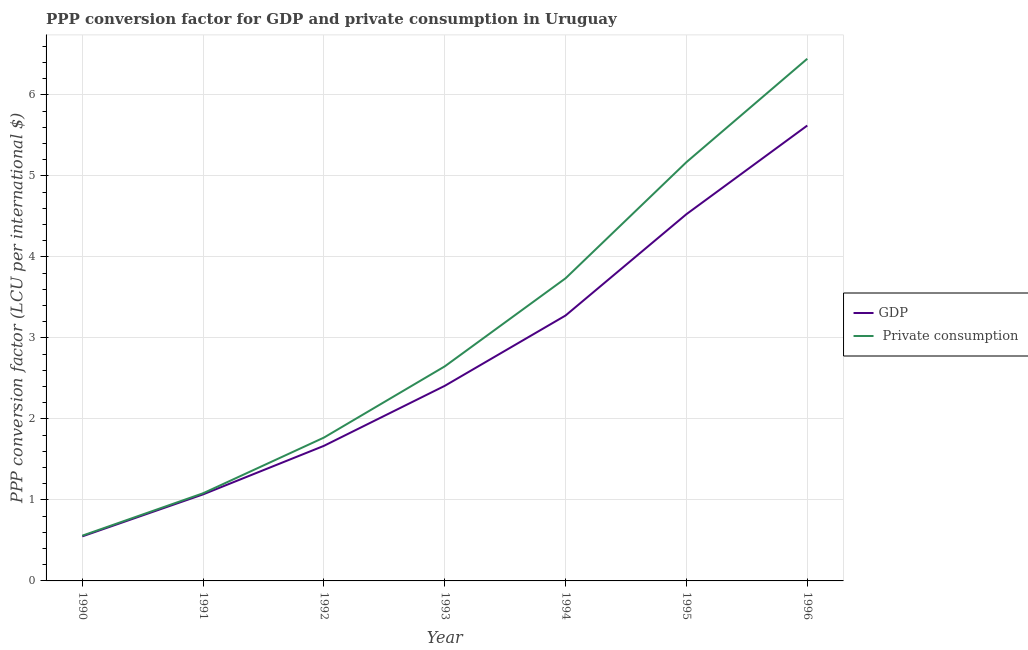How many different coloured lines are there?
Provide a succinct answer. 2. Does the line corresponding to ppp conversion factor for private consumption intersect with the line corresponding to ppp conversion factor for gdp?
Your response must be concise. No. Is the number of lines equal to the number of legend labels?
Your response must be concise. Yes. What is the ppp conversion factor for gdp in 1996?
Offer a terse response. 5.62. Across all years, what is the maximum ppp conversion factor for private consumption?
Give a very brief answer. 6.45. Across all years, what is the minimum ppp conversion factor for gdp?
Make the answer very short. 0.55. In which year was the ppp conversion factor for gdp maximum?
Offer a terse response. 1996. What is the total ppp conversion factor for gdp in the graph?
Your response must be concise. 19.12. What is the difference between the ppp conversion factor for private consumption in 1990 and that in 1991?
Provide a succinct answer. -0.52. What is the difference between the ppp conversion factor for gdp in 1993 and the ppp conversion factor for private consumption in 1992?
Provide a short and direct response. 0.64. What is the average ppp conversion factor for private consumption per year?
Provide a succinct answer. 3.06. In the year 1994, what is the difference between the ppp conversion factor for private consumption and ppp conversion factor for gdp?
Your answer should be very brief. 0.46. What is the ratio of the ppp conversion factor for private consumption in 1991 to that in 1995?
Provide a short and direct response. 0.21. What is the difference between the highest and the second highest ppp conversion factor for private consumption?
Your answer should be very brief. 1.28. What is the difference between the highest and the lowest ppp conversion factor for private consumption?
Provide a succinct answer. 5.89. In how many years, is the ppp conversion factor for private consumption greater than the average ppp conversion factor for private consumption taken over all years?
Your response must be concise. 3. Is the sum of the ppp conversion factor for gdp in 1992 and 1995 greater than the maximum ppp conversion factor for private consumption across all years?
Provide a succinct answer. No. Does the ppp conversion factor for private consumption monotonically increase over the years?
Ensure brevity in your answer.  Yes. Is the ppp conversion factor for private consumption strictly greater than the ppp conversion factor for gdp over the years?
Provide a succinct answer. Yes. Is the ppp conversion factor for gdp strictly less than the ppp conversion factor for private consumption over the years?
Provide a short and direct response. Yes. How many lines are there?
Provide a short and direct response. 2. Are the values on the major ticks of Y-axis written in scientific E-notation?
Provide a succinct answer. No. Does the graph contain any zero values?
Offer a very short reply. No. How many legend labels are there?
Your answer should be very brief. 2. How are the legend labels stacked?
Offer a very short reply. Vertical. What is the title of the graph?
Provide a succinct answer. PPP conversion factor for GDP and private consumption in Uruguay. What is the label or title of the Y-axis?
Provide a succinct answer. PPP conversion factor (LCU per international $). What is the PPP conversion factor (LCU per international $) of GDP in 1990?
Ensure brevity in your answer.  0.55. What is the PPP conversion factor (LCU per international $) in  Private consumption in 1990?
Your answer should be very brief. 0.56. What is the PPP conversion factor (LCU per international $) of GDP in 1991?
Your answer should be very brief. 1.07. What is the PPP conversion factor (LCU per international $) of  Private consumption in 1991?
Offer a terse response. 1.08. What is the PPP conversion factor (LCU per international $) of GDP in 1992?
Give a very brief answer. 1.67. What is the PPP conversion factor (LCU per international $) of  Private consumption in 1992?
Your response must be concise. 1.77. What is the PPP conversion factor (LCU per international $) of GDP in 1993?
Ensure brevity in your answer.  2.41. What is the PPP conversion factor (LCU per international $) in  Private consumption in 1993?
Make the answer very short. 2.65. What is the PPP conversion factor (LCU per international $) of GDP in 1994?
Your answer should be very brief. 3.28. What is the PPP conversion factor (LCU per international $) in  Private consumption in 1994?
Keep it short and to the point. 3.74. What is the PPP conversion factor (LCU per international $) of GDP in 1995?
Provide a succinct answer. 4.53. What is the PPP conversion factor (LCU per international $) in  Private consumption in 1995?
Offer a very short reply. 5.17. What is the PPP conversion factor (LCU per international $) of GDP in 1996?
Offer a very short reply. 5.62. What is the PPP conversion factor (LCU per international $) in  Private consumption in 1996?
Keep it short and to the point. 6.45. Across all years, what is the maximum PPP conversion factor (LCU per international $) of GDP?
Make the answer very short. 5.62. Across all years, what is the maximum PPP conversion factor (LCU per international $) in  Private consumption?
Provide a succinct answer. 6.45. Across all years, what is the minimum PPP conversion factor (LCU per international $) in GDP?
Offer a terse response. 0.55. Across all years, what is the minimum PPP conversion factor (LCU per international $) of  Private consumption?
Your answer should be very brief. 0.56. What is the total PPP conversion factor (LCU per international $) of GDP in the graph?
Offer a very short reply. 19.12. What is the total PPP conversion factor (LCU per international $) of  Private consumption in the graph?
Give a very brief answer. 21.41. What is the difference between the PPP conversion factor (LCU per international $) of GDP in 1990 and that in 1991?
Your response must be concise. -0.52. What is the difference between the PPP conversion factor (LCU per international $) of  Private consumption in 1990 and that in 1991?
Provide a succinct answer. -0.52. What is the difference between the PPP conversion factor (LCU per international $) of GDP in 1990 and that in 1992?
Keep it short and to the point. -1.12. What is the difference between the PPP conversion factor (LCU per international $) in  Private consumption in 1990 and that in 1992?
Offer a very short reply. -1.21. What is the difference between the PPP conversion factor (LCU per international $) of GDP in 1990 and that in 1993?
Your answer should be compact. -1.86. What is the difference between the PPP conversion factor (LCU per international $) in  Private consumption in 1990 and that in 1993?
Your answer should be very brief. -2.09. What is the difference between the PPP conversion factor (LCU per international $) in GDP in 1990 and that in 1994?
Your answer should be very brief. -2.73. What is the difference between the PPP conversion factor (LCU per international $) of  Private consumption in 1990 and that in 1994?
Give a very brief answer. -3.18. What is the difference between the PPP conversion factor (LCU per international $) of GDP in 1990 and that in 1995?
Keep it short and to the point. -3.98. What is the difference between the PPP conversion factor (LCU per international $) of  Private consumption in 1990 and that in 1995?
Your answer should be compact. -4.61. What is the difference between the PPP conversion factor (LCU per international $) of GDP in 1990 and that in 1996?
Your answer should be very brief. -5.07. What is the difference between the PPP conversion factor (LCU per international $) in  Private consumption in 1990 and that in 1996?
Your response must be concise. -5.89. What is the difference between the PPP conversion factor (LCU per international $) of GDP in 1991 and that in 1992?
Give a very brief answer. -0.6. What is the difference between the PPP conversion factor (LCU per international $) in  Private consumption in 1991 and that in 1992?
Your response must be concise. -0.69. What is the difference between the PPP conversion factor (LCU per international $) of GDP in 1991 and that in 1993?
Give a very brief answer. -1.34. What is the difference between the PPP conversion factor (LCU per international $) of  Private consumption in 1991 and that in 1993?
Provide a succinct answer. -1.57. What is the difference between the PPP conversion factor (LCU per international $) of GDP in 1991 and that in 1994?
Offer a terse response. -2.21. What is the difference between the PPP conversion factor (LCU per international $) in  Private consumption in 1991 and that in 1994?
Provide a succinct answer. -2.65. What is the difference between the PPP conversion factor (LCU per international $) in GDP in 1991 and that in 1995?
Your response must be concise. -3.46. What is the difference between the PPP conversion factor (LCU per international $) of  Private consumption in 1991 and that in 1995?
Your answer should be very brief. -4.09. What is the difference between the PPP conversion factor (LCU per international $) of GDP in 1991 and that in 1996?
Ensure brevity in your answer.  -4.55. What is the difference between the PPP conversion factor (LCU per international $) of  Private consumption in 1991 and that in 1996?
Your answer should be compact. -5.36. What is the difference between the PPP conversion factor (LCU per international $) of GDP in 1992 and that in 1993?
Keep it short and to the point. -0.74. What is the difference between the PPP conversion factor (LCU per international $) in  Private consumption in 1992 and that in 1993?
Provide a short and direct response. -0.88. What is the difference between the PPP conversion factor (LCU per international $) of GDP in 1992 and that in 1994?
Offer a terse response. -1.61. What is the difference between the PPP conversion factor (LCU per international $) of  Private consumption in 1992 and that in 1994?
Offer a very short reply. -1.97. What is the difference between the PPP conversion factor (LCU per international $) in GDP in 1992 and that in 1995?
Provide a short and direct response. -2.86. What is the difference between the PPP conversion factor (LCU per international $) of  Private consumption in 1992 and that in 1995?
Give a very brief answer. -3.4. What is the difference between the PPP conversion factor (LCU per international $) of GDP in 1992 and that in 1996?
Offer a terse response. -3.95. What is the difference between the PPP conversion factor (LCU per international $) of  Private consumption in 1992 and that in 1996?
Provide a succinct answer. -4.68. What is the difference between the PPP conversion factor (LCU per international $) of GDP in 1993 and that in 1994?
Offer a terse response. -0.87. What is the difference between the PPP conversion factor (LCU per international $) in  Private consumption in 1993 and that in 1994?
Keep it short and to the point. -1.09. What is the difference between the PPP conversion factor (LCU per international $) of GDP in 1993 and that in 1995?
Provide a short and direct response. -2.12. What is the difference between the PPP conversion factor (LCU per international $) of  Private consumption in 1993 and that in 1995?
Make the answer very short. -2.52. What is the difference between the PPP conversion factor (LCU per international $) of GDP in 1993 and that in 1996?
Keep it short and to the point. -3.21. What is the difference between the PPP conversion factor (LCU per international $) in  Private consumption in 1993 and that in 1996?
Your answer should be compact. -3.8. What is the difference between the PPP conversion factor (LCU per international $) in GDP in 1994 and that in 1995?
Keep it short and to the point. -1.25. What is the difference between the PPP conversion factor (LCU per international $) of  Private consumption in 1994 and that in 1995?
Make the answer very short. -1.43. What is the difference between the PPP conversion factor (LCU per international $) in GDP in 1994 and that in 1996?
Your response must be concise. -2.34. What is the difference between the PPP conversion factor (LCU per international $) in  Private consumption in 1994 and that in 1996?
Ensure brevity in your answer.  -2.71. What is the difference between the PPP conversion factor (LCU per international $) of GDP in 1995 and that in 1996?
Your answer should be compact. -1.09. What is the difference between the PPP conversion factor (LCU per international $) of  Private consumption in 1995 and that in 1996?
Provide a short and direct response. -1.28. What is the difference between the PPP conversion factor (LCU per international $) of GDP in 1990 and the PPP conversion factor (LCU per international $) of  Private consumption in 1991?
Your response must be concise. -0.53. What is the difference between the PPP conversion factor (LCU per international $) in GDP in 1990 and the PPP conversion factor (LCU per international $) in  Private consumption in 1992?
Provide a short and direct response. -1.22. What is the difference between the PPP conversion factor (LCU per international $) in GDP in 1990 and the PPP conversion factor (LCU per international $) in  Private consumption in 1993?
Offer a very short reply. -2.1. What is the difference between the PPP conversion factor (LCU per international $) of GDP in 1990 and the PPP conversion factor (LCU per international $) of  Private consumption in 1994?
Offer a very short reply. -3.19. What is the difference between the PPP conversion factor (LCU per international $) in GDP in 1990 and the PPP conversion factor (LCU per international $) in  Private consumption in 1995?
Provide a short and direct response. -4.62. What is the difference between the PPP conversion factor (LCU per international $) of GDP in 1990 and the PPP conversion factor (LCU per international $) of  Private consumption in 1996?
Offer a terse response. -5.9. What is the difference between the PPP conversion factor (LCU per international $) in GDP in 1991 and the PPP conversion factor (LCU per international $) in  Private consumption in 1992?
Provide a short and direct response. -0.7. What is the difference between the PPP conversion factor (LCU per international $) in GDP in 1991 and the PPP conversion factor (LCU per international $) in  Private consumption in 1993?
Provide a short and direct response. -1.58. What is the difference between the PPP conversion factor (LCU per international $) in GDP in 1991 and the PPP conversion factor (LCU per international $) in  Private consumption in 1994?
Your answer should be very brief. -2.67. What is the difference between the PPP conversion factor (LCU per international $) in GDP in 1991 and the PPP conversion factor (LCU per international $) in  Private consumption in 1995?
Your answer should be compact. -4.1. What is the difference between the PPP conversion factor (LCU per international $) in GDP in 1991 and the PPP conversion factor (LCU per international $) in  Private consumption in 1996?
Give a very brief answer. -5.38. What is the difference between the PPP conversion factor (LCU per international $) in GDP in 1992 and the PPP conversion factor (LCU per international $) in  Private consumption in 1993?
Make the answer very short. -0.98. What is the difference between the PPP conversion factor (LCU per international $) of GDP in 1992 and the PPP conversion factor (LCU per international $) of  Private consumption in 1994?
Your response must be concise. -2.07. What is the difference between the PPP conversion factor (LCU per international $) of GDP in 1992 and the PPP conversion factor (LCU per international $) of  Private consumption in 1995?
Ensure brevity in your answer.  -3.5. What is the difference between the PPP conversion factor (LCU per international $) of GDP in 1992 and the PPP conversion factor (LCU per international $) of  Private consumption in 1996?
Offer a very short reply. -4.78. What is the difference between the PPP conversion factor (LCU per international $) in GDP in 1993 and the PPP conversion factor (LCU per international $) in  Private consumption in 1994?
Provide a succinct answer. -1.33. What is the difference between the PPP conversion factor (LCU per international $) in GDP in 1993 and the PPP conversion factor (LCU per international $) in  Private consumption in 1995?
Make the answer very short. -2.76. What is the difference between the PPP conversion factor (LCU per international $) in GDP in 1993 and the PPP conversion factor (LCU per international $) in  Private consumption in 1996?
Ensure brevity in your answer.  -4.04. What is the difference between the PPP conversion factor (LCU per international $) in GDP in 1994 and the PPP conversion factor (LCU per international $) in  Private consumption in 1995?
Your response must be concise. -1.89. What is the difference between the PPP conversion factor (LCU per international $) of GDP in 1994 and the PPP conversion factor (LCU per international $) of  Private consumption in 1996?
Give a very brief answer. -3.17. What is the difference between the PPP conversion factor (LCU per international $) in GDP in 1995 and the PPP conversion factor (LCU per international $) in  Private consumption in 1996?
Give a very brief answer. -1.92. What is the average PPP conversion factor (LCU per international $) of GDP per year?
Offer a terse response. 2.73. What is the average PPP conversion factor (LCU per international $) in  Private consumption per year?
Make the answer very short. 3.06. In the year 1990, what is the difference between the PPP conversion factor (LCU per international $) in GDP and PPP conversion factor (LCU per international $) in  Private consumption?
Ensure brevity in your answer.  -0.01. In the year 1991, what is the difference between the PPP conversion factor (LCU per international $) in GDP and PPP conversion factor (LCU per international $) in  Private consumption?
Offer a very short reply. -0.01. In the year 1992, what is the difference between the PPP conversion factor (LCU per international $) of GDP and PPP conversion factor (LCU per international $) of  Private consumption?
Offer a terse response. -0.1. In the year 1993, what is the difference between the PPP conversion factor (LCU per international $) in GDP and PPP conversion factor (LCU per international $) in  Private consumption?
Offer a very short reply. -0.24. In the year 1994, what is the difference between the PPP conversion factor (LCU per international $) in GDP and PPP conversion factor (LCU per international $) in  Private consumption?
Make the answer very short. -0.46. In the year 1995, what is the difference between the PPP conversion factor (LCU per international $) of GDP and PPP conversion factor (LCU per international $) of  Private consumption?
Keep it short and to the point. -0.64. In the year 1996, what is the difference between the PPP conversion factor (LCU per international $) in GDP and PPP conversion factor (LCU per international $) in  Private consumption?
Keep it short and to the point. -0.82. What is the ratio of the PPP conversion factor (LCU per international $) of GDP in 1990 to that in 1991?
Keep it short and to the point. 0.51. What is the ratio of the PPP conversion factor (LCU per international $) in  Private consumption in 1990 to that in 1991?
Offer a very short reply. 0.52. What is the ratio of the PPP conversion factor (LCU per international $) of GDP in 1990 to that in 1992?
Your answer should be compact. 0.33. What is the ratio of the PPP conversion factor (LCU per international $) in  Private consumption in 1990 to that in 1992?
Ensure brevity in your answer.  0.32. What is the ratio of the PPP conversion factor (LCU per international $) in GDP in 1990 to that in 1993?
Provide a succinct answer. 0.23. What is the ratio of the PPP conversion factor (LCU per international $) in  Private consumption in 1990 to that in 1993?
Give a very brief answer. 0.21. What is the ratio of the PPP conversion factor (LCU per international $) of GDP in 1990 to that in 1994?
Keep it short and to the point. 0.17. What is the ratio of the PPP conversion factor (LCU per international $) in  Private consumption in 1990 to that in 1994?
Provide a short and direct response. 0.15. What is the ratio of the PPP conversion factor (LCU per international $) of GDP in 1990 to that in 1995?
Provide a succinct answer. 0.12. What is the ratio of the PPP conversion factor (LCU per international $) of  Private consumption in 1990 to that in 1995?
Give a very brief answer. 0.11. What is the ratio of the PPP conversion factor (LCU per international $) in GDP in 1990 to that in 1996?
Keep it short and to the point. 0.1. What is the ratio of the PPP conversion factor (LCU per international $) of  Private consumption in 1990 to that in 1996?
Your answer should be compact. 0.09. What is the ratio of the PPP conversion factor (LCU per international $) in GDP in 1991 to that in 1992?
Make the answer very short. 0.64. What is the ratio of the PPP conversion factor (LCU per international $) in  Private consumption in 1991 to that in 1992?
Make the answer very short. 0.61. What is the ratio of the PPP conversion factor (LCU per international $) in GDP in 1991 to that in 1993?
Provide a succinct answer. 0.44. What is the ratio of the PPP conversion factor (LCU per international $) in  Private consumption in 1991 to that in 1993?
Make the answer very short. 0.41. What is the ratio of the PPP conversion factor (LCU per international $) of GDP in 1991 to that in 1994?
Provide a succinct answer. 0.33. What is the ratio of the PPP conversion factor (LCU per international $) in  Private consumption in 1991 to that in 1994?
Ensure brevity in your answer.  0.29. What is the ratio of the PPP conversion factor (LCU per international $) in GDP in 1991 to that in 1995?
Give a very brief answer. 0.24. What is the ratio of the PPP conversion factor (LCU per international $) in  Private consumption in 1991 to that in 1995?
Make the answer very short. 0.21. What is the ratio of the PPP conversion factor (LCU per international $) in GDP in 1991 to that in 1996?
Provide a succinct answer. 0.19. What is the ratio of the PPP conversion factor (LCU per international $) of  Private consumption in 1991 to that in 1996?
Your answer should be very brief. 0.17. What is the ratio of the PPP conversion factor (LCU per international $) in GDP in 1992 to that in 1993?
Your answer should be very brief. 0.69. What is the ratio of the PPP conversion factor (LCU per international $) of  Private consumption in 1992 to that in 1993?
Ensure brevity in your answer.  0.67. What is the ratio of the PPP conversion factor (LCU per international $) in GDP in 1992 to that in 1994?
Your answer should be very brief. 0.51. What is the ratio of the PPP conversion factor (LCU per international $) of  Private consumption in 1992 to that in 1994?
Make the answer very short. 0.47. What is the ratio of the PPP conversion factor (LCU per international $) of GDP in 1992 to that in 1995?
Provide a short and direct response. 0.37. What is the ratio of the PPP conversion factor (LCU per international $) in  Private consumption in 1992 to that in 1995?
Keep it short and to the point. 0.34. What is the ratio of the PPP conversion factor (LCU per international $) of GDP in 1992 to that in 1996?
Your response must be concise. 0.3. What is the ratio of the PPP conversion factor (LCU per international $) in  Private consumption in 1992 to that in 1996?
Provide a short and direct response. 0.27. What is the ratio of the PPP conversion factor (LCU per international $) in GDP in 1993 to that in 1994?
Your answer should be very brief. 0.73. What is the ratio of the PPP conversion factor (LCU per international $) in  Private consumption in 1993 to that in 1994?
Provide a succinct answer. 0.71. What is the ratio of the PPP conversion factor (LCU per international $) in GDP in 1993 to that in 1995?
Your response must be concise. 0.53. What is the ratio of the PPP conversion factor (LCU per international $) of  Private consumption in 1993 to that in 1995?
Give a very brief answer. 0.51. What is the ratio of the PPP conversion factor (LCU per international $) in GDP in 1993 to that in 1996?
Your answer should be compact. 0.43. What is the ratio of the PPP conversion factor (LCU per international $) of  Private consumption in 1993 to that in 1996?
Ensure brevity in your answer.  0.41. What is the ratio of the PPP conversion factor (LCU per international $) in GDP in 1994 to that in 1995?
Ensure brevity in your answer.  0.72. What is the ratio of the PPP conversion factor (LCU per international $) of  Private consumption in 1994 to that in 1995?
Offer a terse response. 0.72. What is the ratio of the PPP conversion factor (LCU per international $) of GDP in 1994 to that in 1996?
Ensure brevity in your answer.  0.58. What is the ratio of the PPP conversion factor (LCU per international $) in  Private consumption in 1994 to that in 1996?
Your response must be concise. 0.58. What is the ratio of the PPP conversion factor (LCU per international $) of GDP in 1995 to that in 1996?
Offer a very short reply. 0.81. What is the ratio of the PPP conversion factor (LCU per international $) of  Private consumption in 1995 to that in 1996?
Keep it short and to the point. 0.8. What is the difference between the highest and the second highest PPP conversion factor (LCU per international $) of GDP?
Provide a succinct answer. 1.09. What is the difference between the highest and the second highest PPP conversion factor (LCU per international $) in  Private consumption?
Offer a very short reply. 1.28. What is the difference between the highest and the lowest PPP conversion factor (LCU per international $) of GDP?
Provide a succinct answer. 5.07. What is the difference between the highest and the lowest PPP conversion factor (LCU per international $) of  Private consumption?
Make the answer very short. 5.89. 